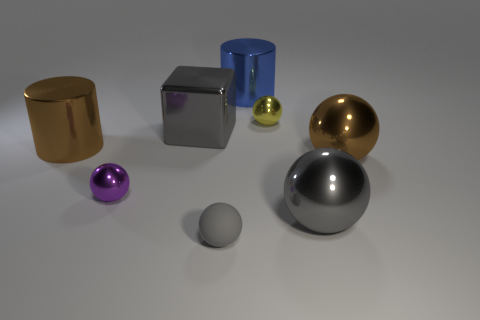Subtract all small spheres. How many spheres are left? 2 Add 1 small purple metallic things. How many objects exist? 9 Subtract all blue cylinders. How many cylinders are left? 1 Subtract all cylinders. How many objects are left? 6 Subtract 2 cylinders. How many cylinders are left? 0 Subtract 0 purple cylinders. How many objects are left? 8 Subtract all brown cubes. Subtract all brown spheres. How many cubes are left? 1 Subtract all cyan cylinders. How many yellow blocks are left? 0 Subtract all blue shiny things. Subtract all big cubes. How many objects are left? 6 Add 7 purple spheres. How many purple spheres are left? 8 